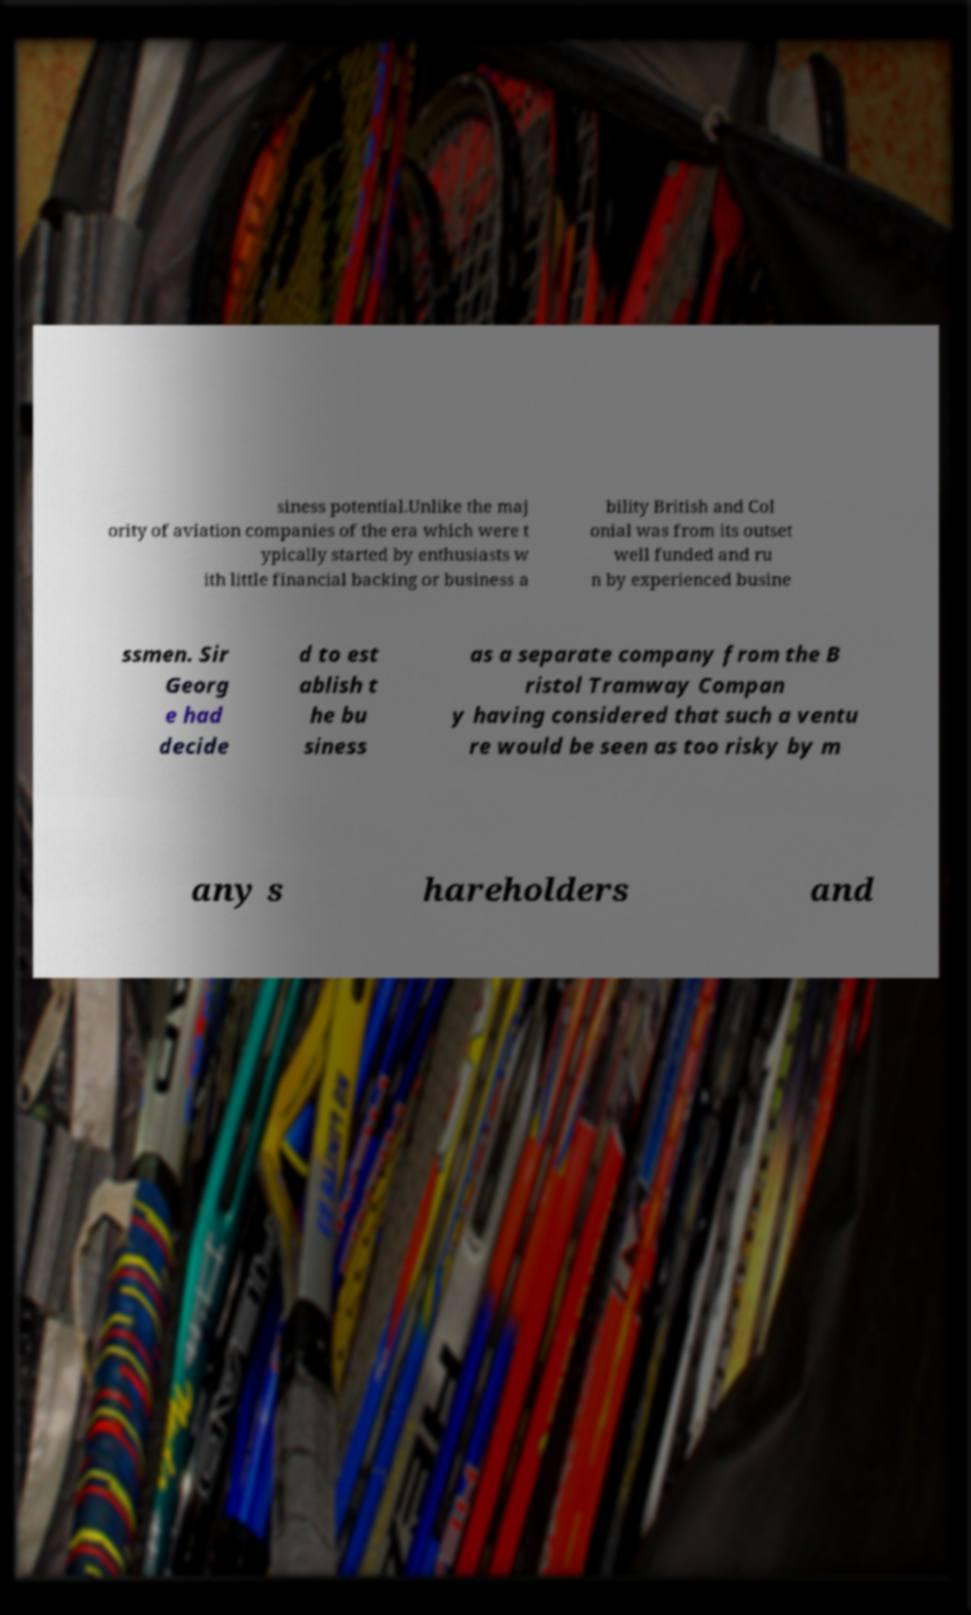Could you assist in decoding the text presented in this image and type it out clearly? siness potential.Unlike the maj ority of aviation companies of the era which were t ypically started by enthusiasts w ith little financial backing or business a bility British and Col onial was from its outset well funded and ru n by experienced busine ssmen. Sir Georg e had decide d to est ablish t he bu siness as a separate company from the B ristol Tramway Compan y having considered that such a ventu re would be seen as too risky by m any s hareholders and 